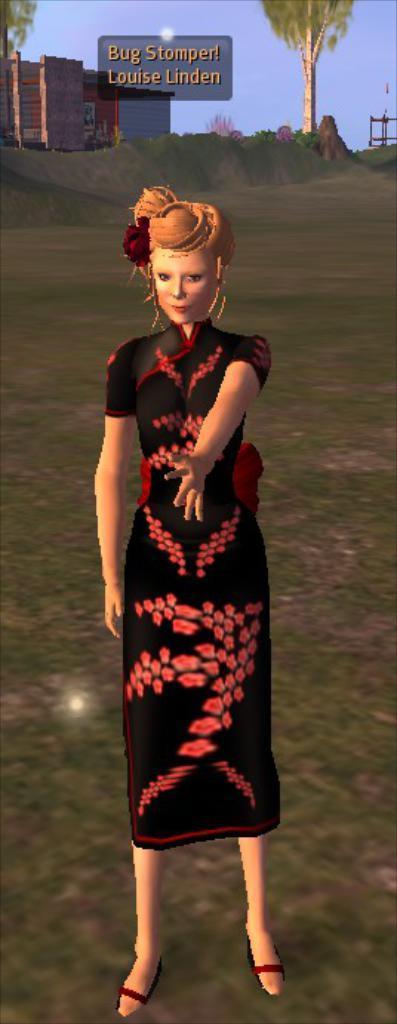In one or two sentences, can you explain what this image depicts? This is an animated picture. I can see a woman standing, there are buildings, trees, it is looking like a board, and in the background there is sky. 